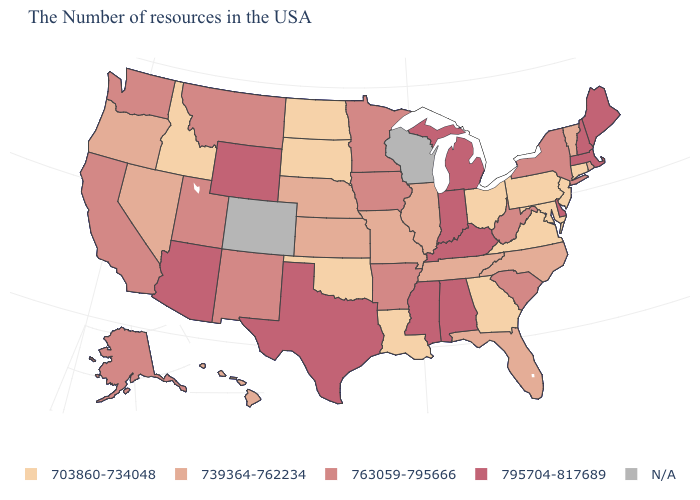Which states have the lowest value in the USA?
Quick response, please. Connecticut, New Jersey, Maryland, Pennsylvania, Virginia, Ohio, Georgia, Louisiana, Oklahoma, South Dakota, North Dakota, Idaho. What is the value of Pennsylvania?
Write a very short answer. 703860-734048. Name the states that have a value in the range 703860-734048?
Be succinct. Connecticut, New Jersey, Maryland, Pennsylvania, Virginia, Ohio, Georgia, Louisiana, Oklahoma, South Dakota, North Dakota, Idaho. What is the value of Ohio?
Give a very brief answer. 703860-734048. Among the states that border Montana , does Idaho have the highest value?
Be succinct. No. Does Idaho have the lowest value in the USA?
Short answer required. Yes. What is the value of New Jersey?
Keep it brief. 703860-734048. What is the highest value in the Northeast ?
Write a very short answer. 795704-817689. Which states have the highest value in the USA?
Be succinct. Maine, Massachusetts, New Hampshire, Delaware, Michigan, Kentucky, Indiana, Alabama, Mississippi, Texas, Wyoming, Arizona. What is the value of Oklahoma?
Write a very short answer. 703860-734048. What is the value of North Dakota?
Concise answer only. 703860-734048. Does Maryland have the lowest value in the South?
Quick response, please. Yes. Name the states that have a value in the range 739364-762234?
Be succinct. Rhode Island, Vermont, North Carolina, Florida, Tennessee, Illinois, Missouri, Kansas, Nebraska, Nevada, Oregon, Hawaii. 